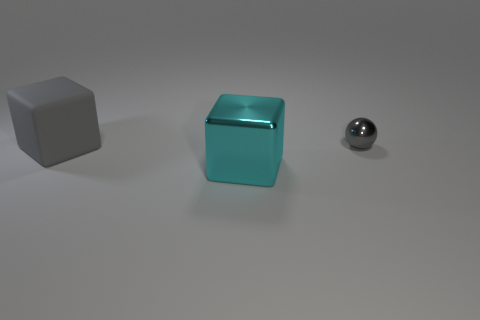What number of cyan things are in front of the cube that is behind the large cyan thing?
Ensure brevity in your answer.  1. What number of other objects are the same shape as the big metal thing?
Offer a very short reply. 1. What material is the other thing that is the same color as the rubber thing?
Keep it short and to the point. Metal. How many small objects have the same color as the tiny sphere?
Your response must be concise. 0. There is a big block that is the same material as the small ball; what color is it?
Provide a succinct answer. Cyan. Are there any shiny cubes of the same size as the matte cube?
Provide a succinct answer. Yes. Is the number of large gray rubber blocks that are in front of the cyan object greater than the number of balls behind the large gray matte cube?
Ensure brevity in your answer.  No. Does the large object that is right of the big gray cube have the same material as the gray object that is right of the big gray block?
Keep it short and to the point. Yes. There is another thing that is the same size as the gray matte thing; what is its shape?
Your answer should be very brief. Cube. Are there any tiny metallic objects of the same shape as the matte object?
Offer a very short reply. No. 